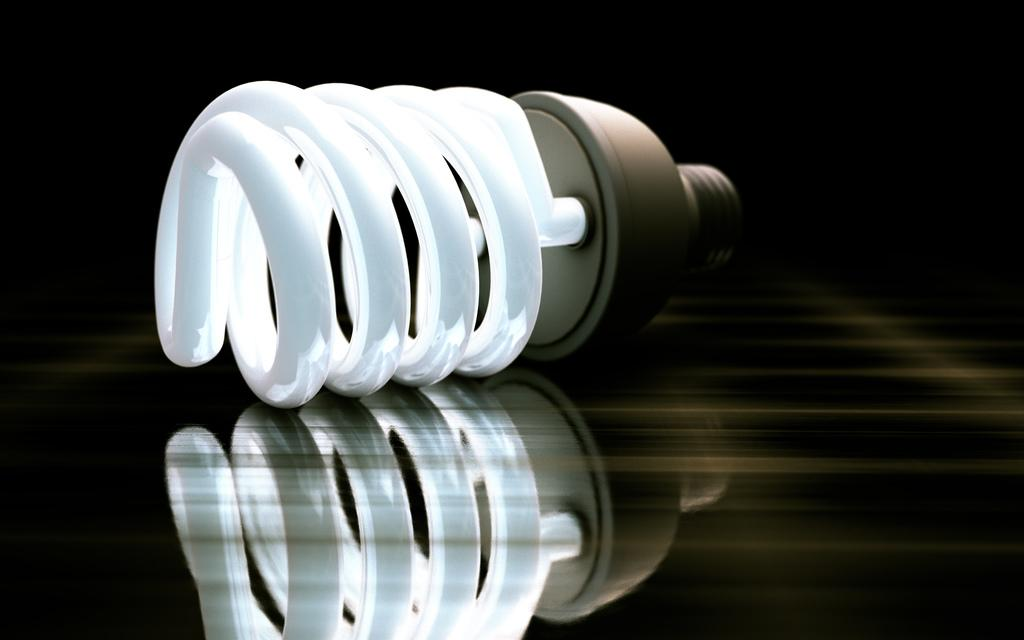What object is on the floor in the image? There is an LED bulb on the floor in the image. Can you describe the lighting conditions in the image? The image was likely taken during the night, as indicated by the presence of the LED bulb. How many trees can be seen in the image? There are no trees visible in the image. What type of ear is present in the image? There is no ear present in the image. 